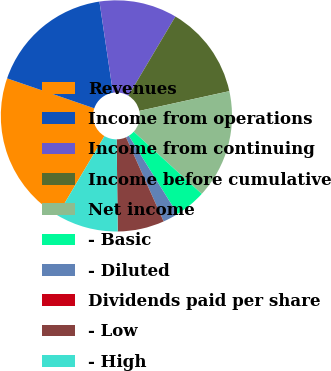Convert chart to OTSL. <chart><loc_0><loc_0><loc_500><loc_500><pie_chart><fcel>Revenues<fcel>Income from operations<fcel>Income from continuing<fcel>Income before cumulative<fcel>Net income<fcel>- Basic<fcel>- Diluted<fcel>Dividends paid per share<fcel>- Low<fcel>- High<nl><fcel>21.74%<fcel>17.39%<fcel>10.87%<fcel>13.04%<fcel>15.22%<fcel>4.35%<fcel>2.17%<fcel>0.0%<fcel>6.52%<fcel>8.7%<nl></chart> 